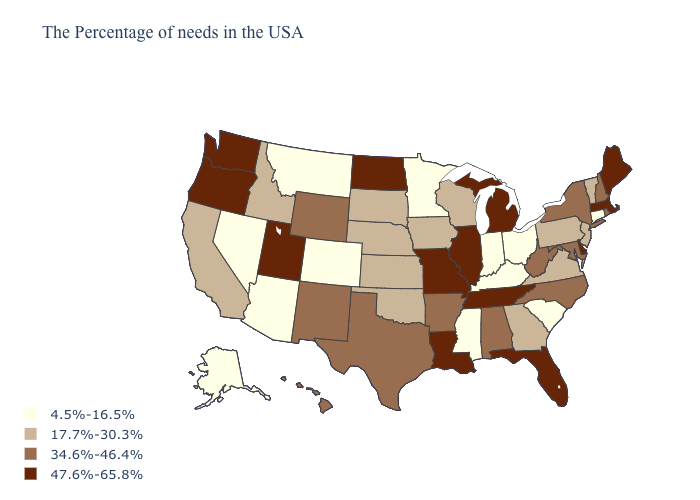Name the states that have a value in the range 17.7%-30.3%?
Concise answer only. Vermont, New Jersey, Pennsylvania, Virginia, Georgia, Wisconsin, Iowa, Kansas, Nebraska, Oklahoma, South Dakota, Idaho, California. What is the highest value in the USA?
Write a very short answer. 47.6%-65.8%. What is the value of Tennessee?
Concise answer only. 47.6%-65.8%. Does Connecticut have the lowest value in the USA?
Quick response, please. Yes. What is the value of Georgia?
Keep it brief. 17.7%-30.3%. Does Oregon have the lowest value in the USA?
Concise answer only. No. What is the value of Tennessee?
Keep it brief. 47.6%-65.8%. Does Hawaii have the highest value in the USA?
Quick response, please. No. What is the value of Indiana?
Concise answer only. 4.5%-16.5%. Name the states that have a value in the range 47.6%-65.8%?
Give a very brief answer. Maine, Massachusetts, Delaware, Florida, Michigan, Tennessee, Illinois, Louisiana, Missouri, North Dakota, Utah, Washington, Oregon. Does Louisiana have the highest value in the USA?
Write a very short answer. Yes. Is the legend a continuous bar?
Answer briefly. No. Name the states that have a value in the range 47.6%-65.8%?
Short answer required. Maine, Massachusetts, Delaware, Florida, Michigan, Tennessee, Illinois, Louisiana, Missouri, North Dakota, Utah, Washington, Oregon. Name the states that have a value in the range 17.7%-30.3%?
Write a very short answer. Vermont, New Jersey, Pennsylvania, Virginia, Georgia, Wisconsin, Iowa, Kansas, Nebraska, Oklahoma, South Dakota, Idaho, California. What is the lowest value in the USA?
Give a very brief answer. 4.5%-16.5%. 